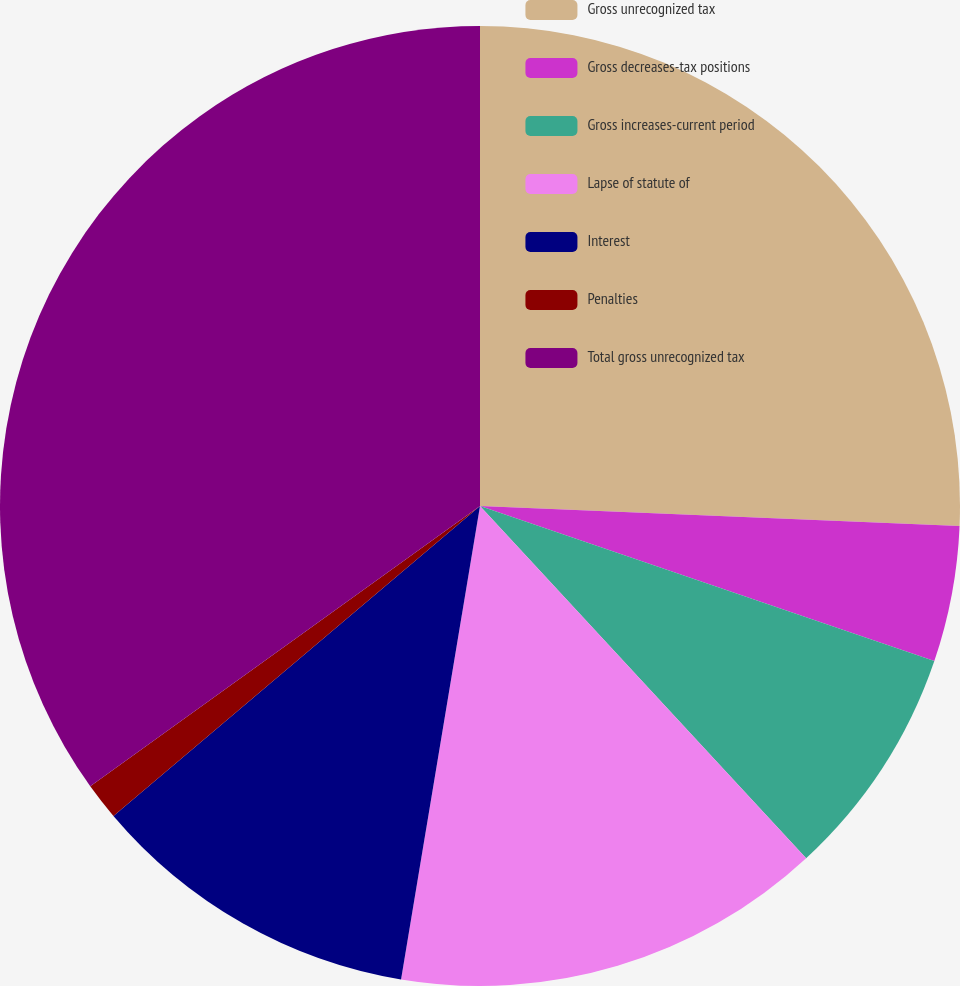<chart> <loc_0><loc_0><loc_500><loc_500><pie_chart><fcel>Gross unrecognized tax<fcel>Gross decreases-tax positions<fcel>Gross increases-current period<fcel>Lapse of statute of<fcel>Interest<fcel>Penalties<fcel>Total gross unrecognized tax<nl><fcel>25.66%<fcel>4.57%<fcel>7.88%<fcel>14.52%<fcel>11.2%<fcel>1.25%<fcel>34.92%<nl></chart> 